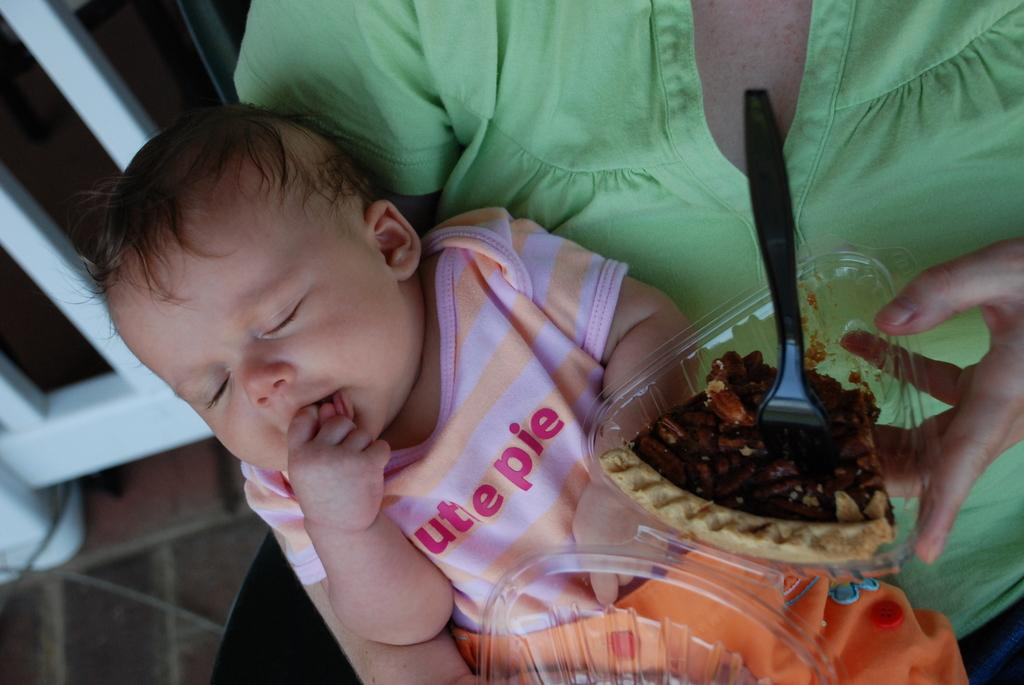Who is the main subject in the image? There is a woman in the image. What is the woman holding in the image? The woman is holding a baby and a bowl containing food. What is inside the bowl? The bowl contains a spoon. What can be seen in the background of the image? There are metal poles in the background of the image. What type of vessel can be seen sailing in the background of the image? There is no vessel sailing in the background of the image; it only features metal poles. 